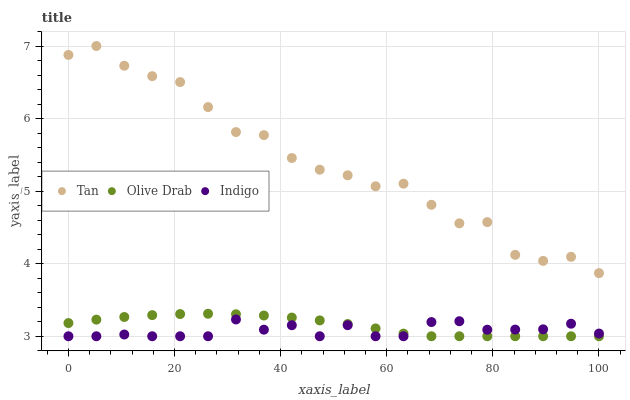Does Indigo have the minimum area under the curve?
Answer yes or no. Yes. Does Tan have the maximum area under the curve?
Answer yes or no. Yes. Does Olive Drab have the minimum area under the curve?
Answer yes or no. No. Does Olive Drab have the maximum area under the curve?
Answer yes or no. No. Is Olive Drab the smoothest?
Answer yes or no. Yes. Is Tan the roughest?
Answer yes or no. Yes. Is Indigo the smoothest?
Answer yes or no. No. Is Indigo the roughest?
Answer yes or no. No. Does Indigo have the lowest value?
Answer yes or no. Yes. Does Tan have the highest value?
Answer yes or no. Yes. Does Olive Drab have the highest value?
Answer yes or no. No. Is Olive Drab less than Tan?
Answer yes or no. Yes. Is Tan greater than Indigo?
Answer yes or no. Yes. Does Olive Drab intersect Indigo?
Answer yes or no. Yes. Is Olive Drab less than Indigo?
Answer yes or no. No. Is Olive Drab greater than Indigo?
Answer yes or no. No. Does Olive Drab intersect Tan?
Answer yes or no. No. 